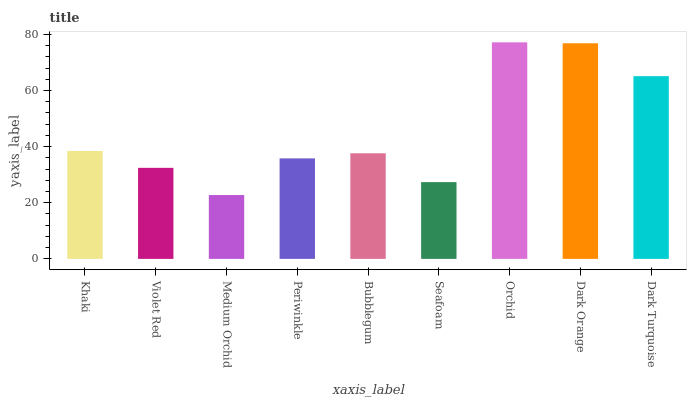Is Medium Orchid the minimum?
Answer yes or no. Yes. Is Orchid the maximum?
Answer yes or no. Yes. Is Violet Red the minimum?
Answer yes or no. No. Is Violet Red the maximum?
Answer yes or no. No. Is Khaki greater than Violet Red?
Answer yes or no. Yes. Is Violet Red less than Khaki?
Answer yes or no. Yes. Is Violet Red greater than Khaki?
Answer yes or no. No. Is Khaki less than Violet Red?
Answer yes or no. No. Is Bubblegum the high median?
Answer yes or no. Yes. Is Bubblegum the low median?
Answer yes or no. Yes. Is Medium Orchid the high median?
Answer yes or no. No. Is Violet Red the low median?
Answer yes or no. No. 